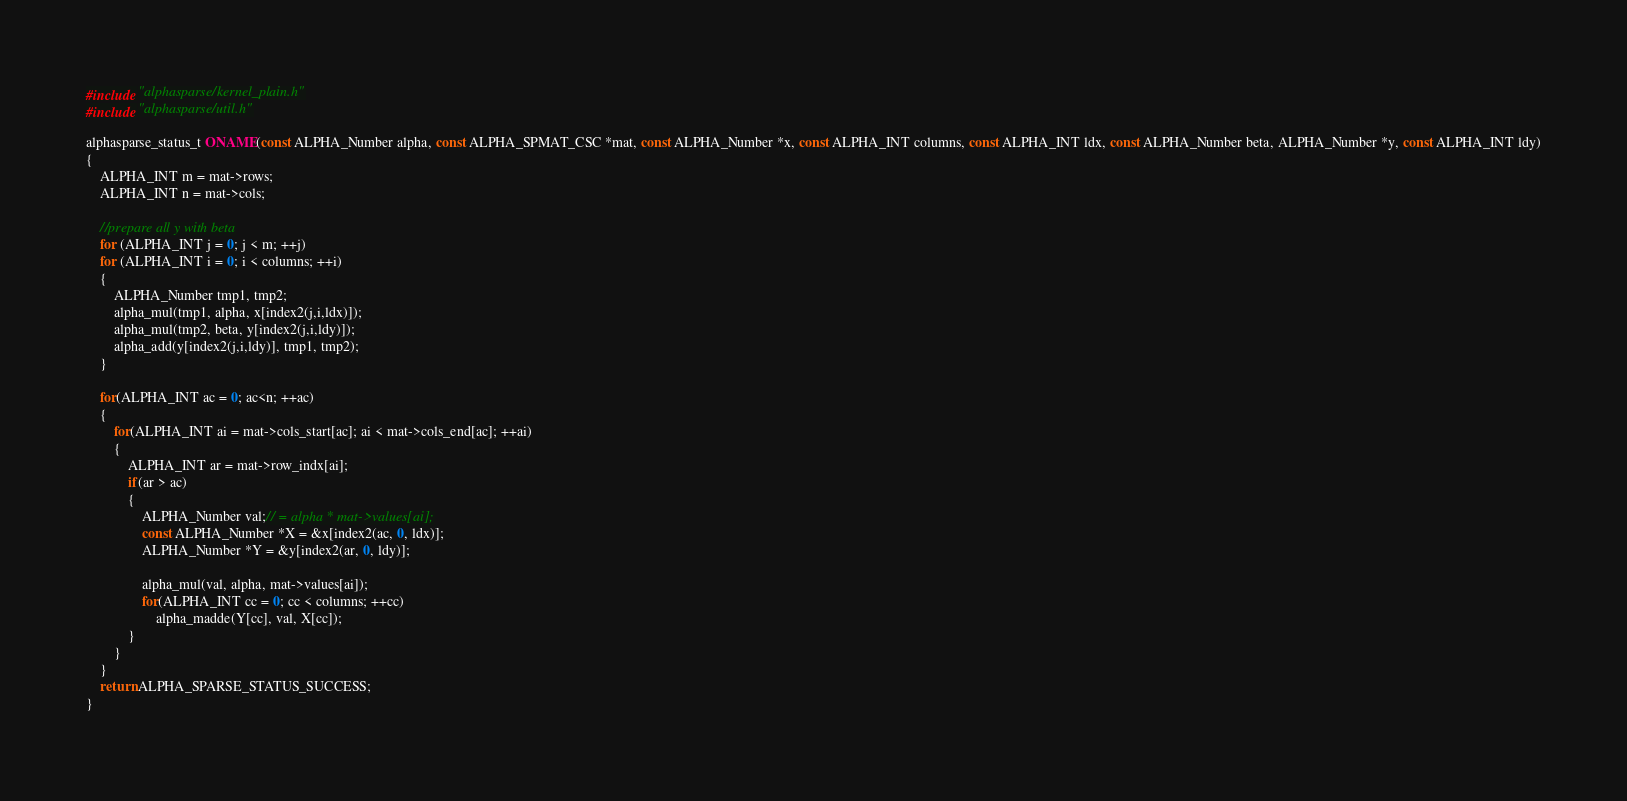<code> <loc_0><loc_0><loc_500><loc_500><_C_>#include "alphasparse/kernel_plain.h"
#include "alphasparse/util.h"

alphasparse_status_t ONAME(const ALPHA_Number alpha, const ALPHA_SPMAT_CSC *mat, const ALPHA_Number *x, const ALPHA_INT columns, const ALPHA_INT ldx, const ALPHA_Number beta, ALPHA_Number *y, const ALPHA_INT ldy)
{
    ALPHA_INT m = mat->rows;
    ALPHA_INT n = mat->cols;

    //prepare all y with beta
    for (ALPHA_INT j = 0; j < m; ++j)
    for (ALPHA_INT i = 0; i < columns; ++i)
    {
        ALPHA_Number tmp1, tmp2;
        alpha_mul(tmp1, alpha, x[index2(j,i,ldx)]);
        alpha_mul(tmp2, beta, y[index2(j,i,ldy)]);
        alpha_add(y[index2(j,i,ldy)], tmp1, tmp2);
    }
    
    for(ALPHA_INT ac = 0; ac<n; ++ac)
    { 
        for(ALPHA_INT ai = mat->cols_start[ac]; ai < mat->cols_end[ac]; ++ai)
        {
            ALPHA_INT ar = mat->row_indx[ai];
            if(ar > ac)
            {
                ALPHA_Number val;// = alpha * mat->values[ai];
                const ALPHA_Number *X = &x[index2(ac, 0, ldx)];
                ALPHA_Number *Y = &y[index2(ar, 0, ldy)];
                
                alpha_mul(val, alpha, mat->values[ai]); 
                for(ALPHA_INT cc = 0; cc < columns; ++cc)
                    alpha_madde(Y[cc], val, X[cc]);
            }
        }
    }
    return ALPHA_SPARSE_STATUS_SUCCESS;
}

</code> 